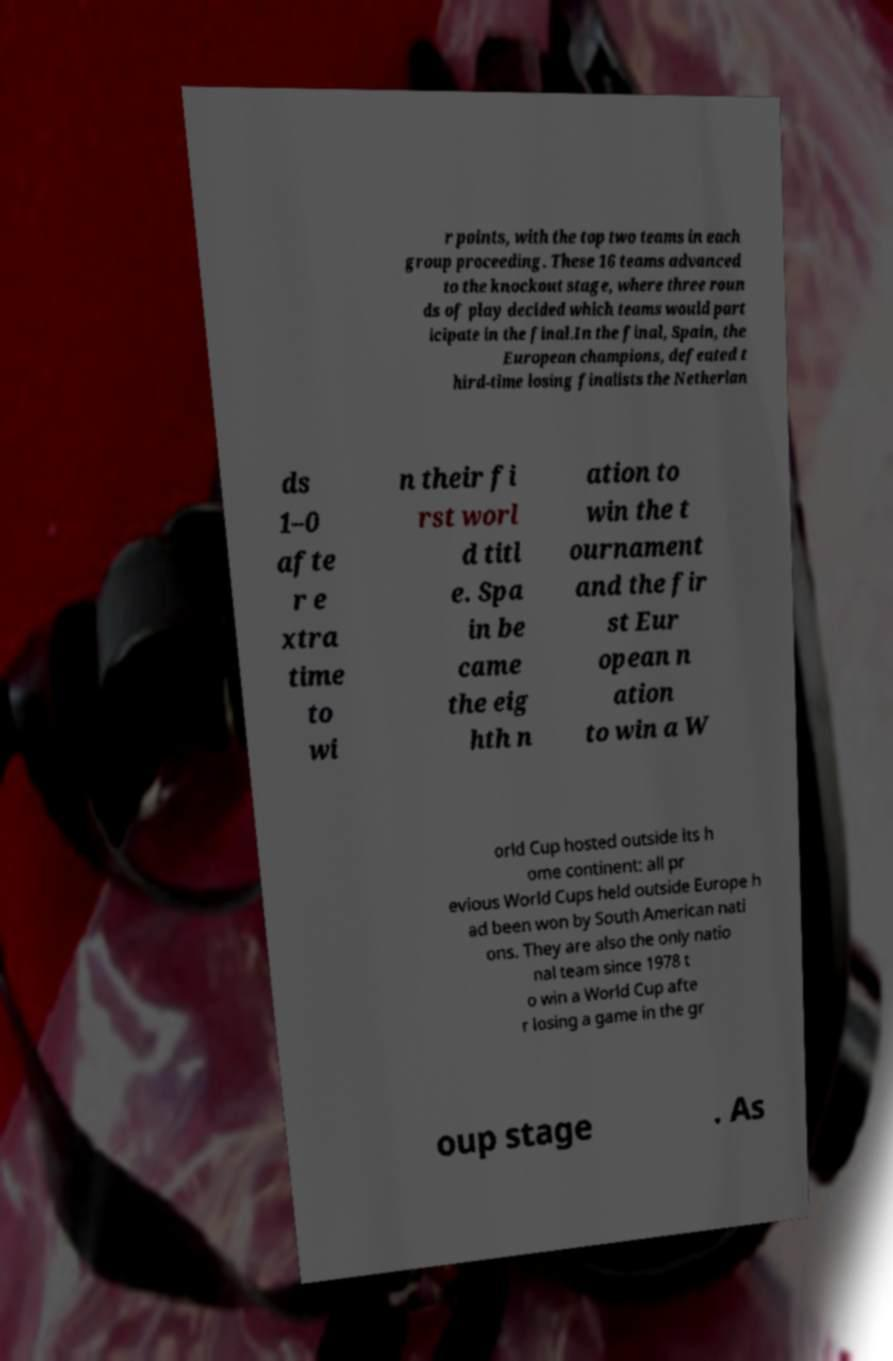For documentation purposes, I need the text within this image transcribed. Could you provide that? r points, with the top two teams in each group proceeding. These 16 teams advanced to the knockout stage, where three roun ds of play decided which teams would part icipate in the final.In the final, Spain, the European champions, defeated t hird-time losing finalists the Netherlan ds 1–0 afte r e xtra time to wi n their fi rst worl d titl e. Spa in be came the eig hth n ation to win the t ournament and the fir st Eur opean n ation to win a W orld Cup hosted outside its h ome continent: all pr evious World Cups held outside Europe h ad been won by South American nati ons. They are also the only natio nal team since 1978 t o win a World Cup afte r losing a game in the gr oup stage . As 